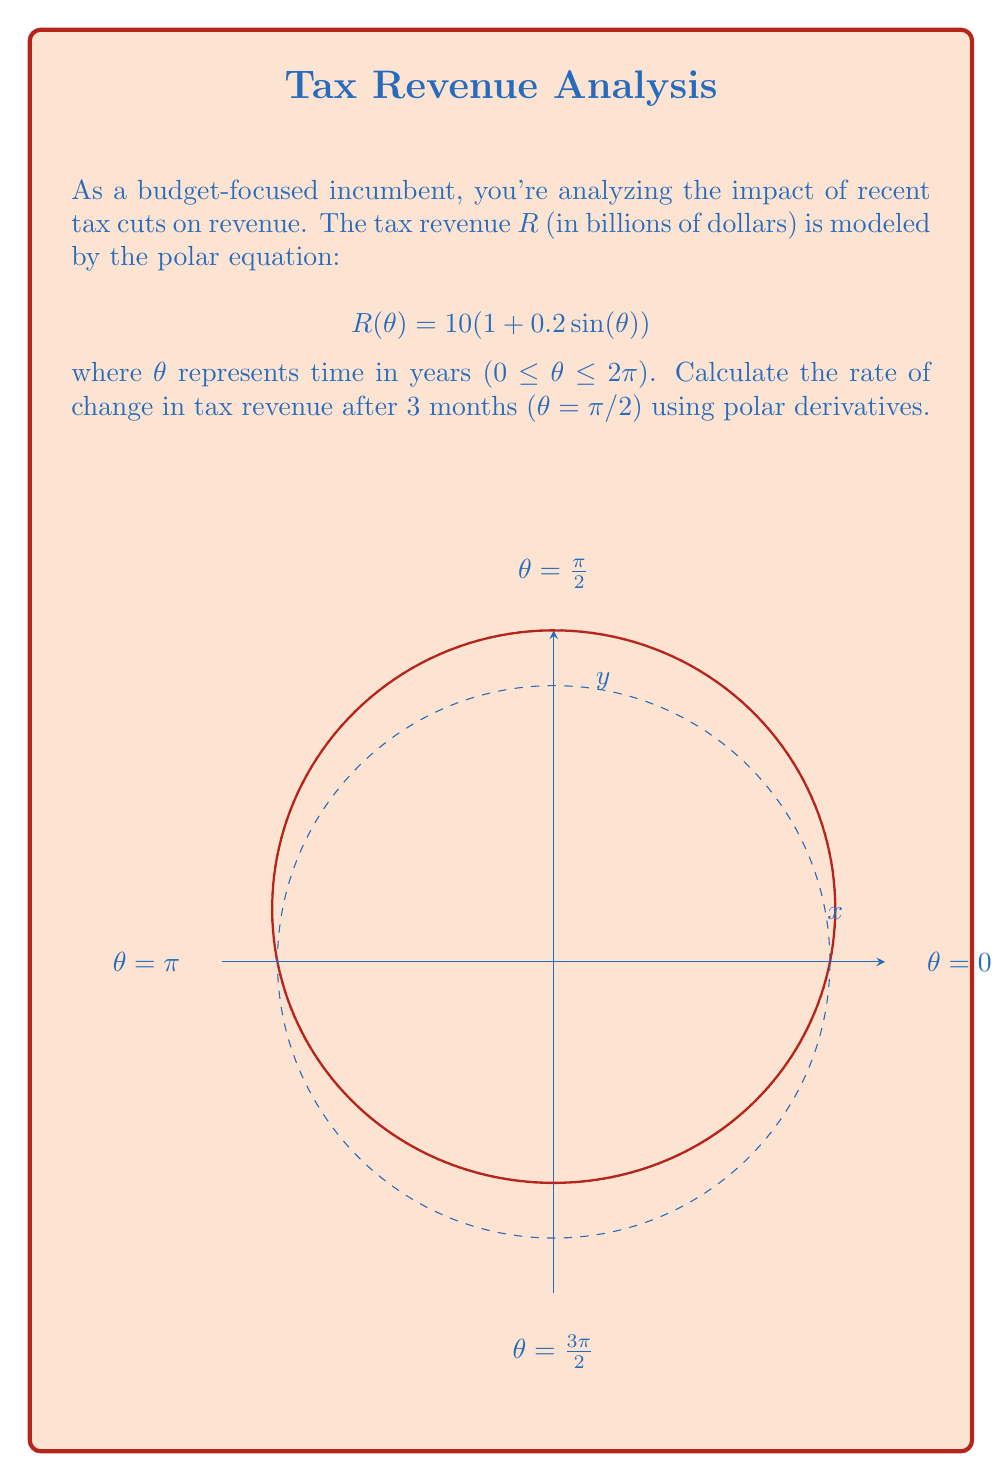What is the answer to this math problem? To find the rate of change in tax revenue using polar derivatives, we need to calculate dR/dθ at θ = π/2. Let's approach this step-by-step:

1) The general formula for the polar derivative is:

   $$\frac{dR}{d\theta} = R'(\theta) = \frac{d}{d\theta}[r(\theta)]$$

2) In our case, $R(\theta) = 10(1 + 0.2\sin(\theta))$

3) To find R'(θ), we differentiate with respect to θ:

   $$R'(\theta) = 10 \cdot 0.2 \cdot \cos(\theta) = 2\cos(\theta)$$

4) Now, we need to evaluate this at θ = π/2:

   $$R'(\pi/2) = 2\cos(\pi/2) = 2 \cdot 0 = 0$$

5) However, this is not the complete answer. In polar coordinates, the actual rate of change is given by:

   $$\frac{dR}{dt} = R'(\theta) \cdot \frac{d\theta}{dt}$$

   Where dθ/dt represents the angular velocity.

6) Assuming a constant angular velocity of 2π radians per year (since θ represents time in years and completes a full cycle in 2π):

   $$\frac{d\theta}{dt} = 2\pi \text{ radians/year}$$

7) Therefore, the final rate of change is:

   $$\frac{dR}{dt} = R'(\pi/2) \cdot \frac{d\theta}{dt} = 0 \cdot 2\pi = 0 \text{ billion dollars/year}$$

This means that at exactly 3 months (θ = π/2), the tax revenue is momentarily neither increasing nor decreasing.
Answer: $0 \text{ billion dollars/year}$ 